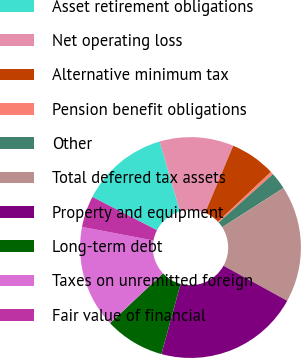Convert chart to OTSL. <chart><loc_0><loc_0><loc_500><loc_500><pie_chart><fcel>Asset retirement obligations<fcel>Net operating loss<fcel>Alternative minimum tax<fcel>Pension benefit obligations<fcel>Other<fcel>Total deferred tax assets<fcel>Property and equipment<fcel>Long-term debt<fcel>Taxes on unremitted foreign<fcel>Fair value of financial<nl><fcel>12.91%<fcel>10.83%<fcel>6.67%<fcel>0.43%<fcel>2.51%<fcel>17.07%<fcel>21.23%<fcel>8.75%<fcel>14.99%<fcel>4.59%<nl></chart> 